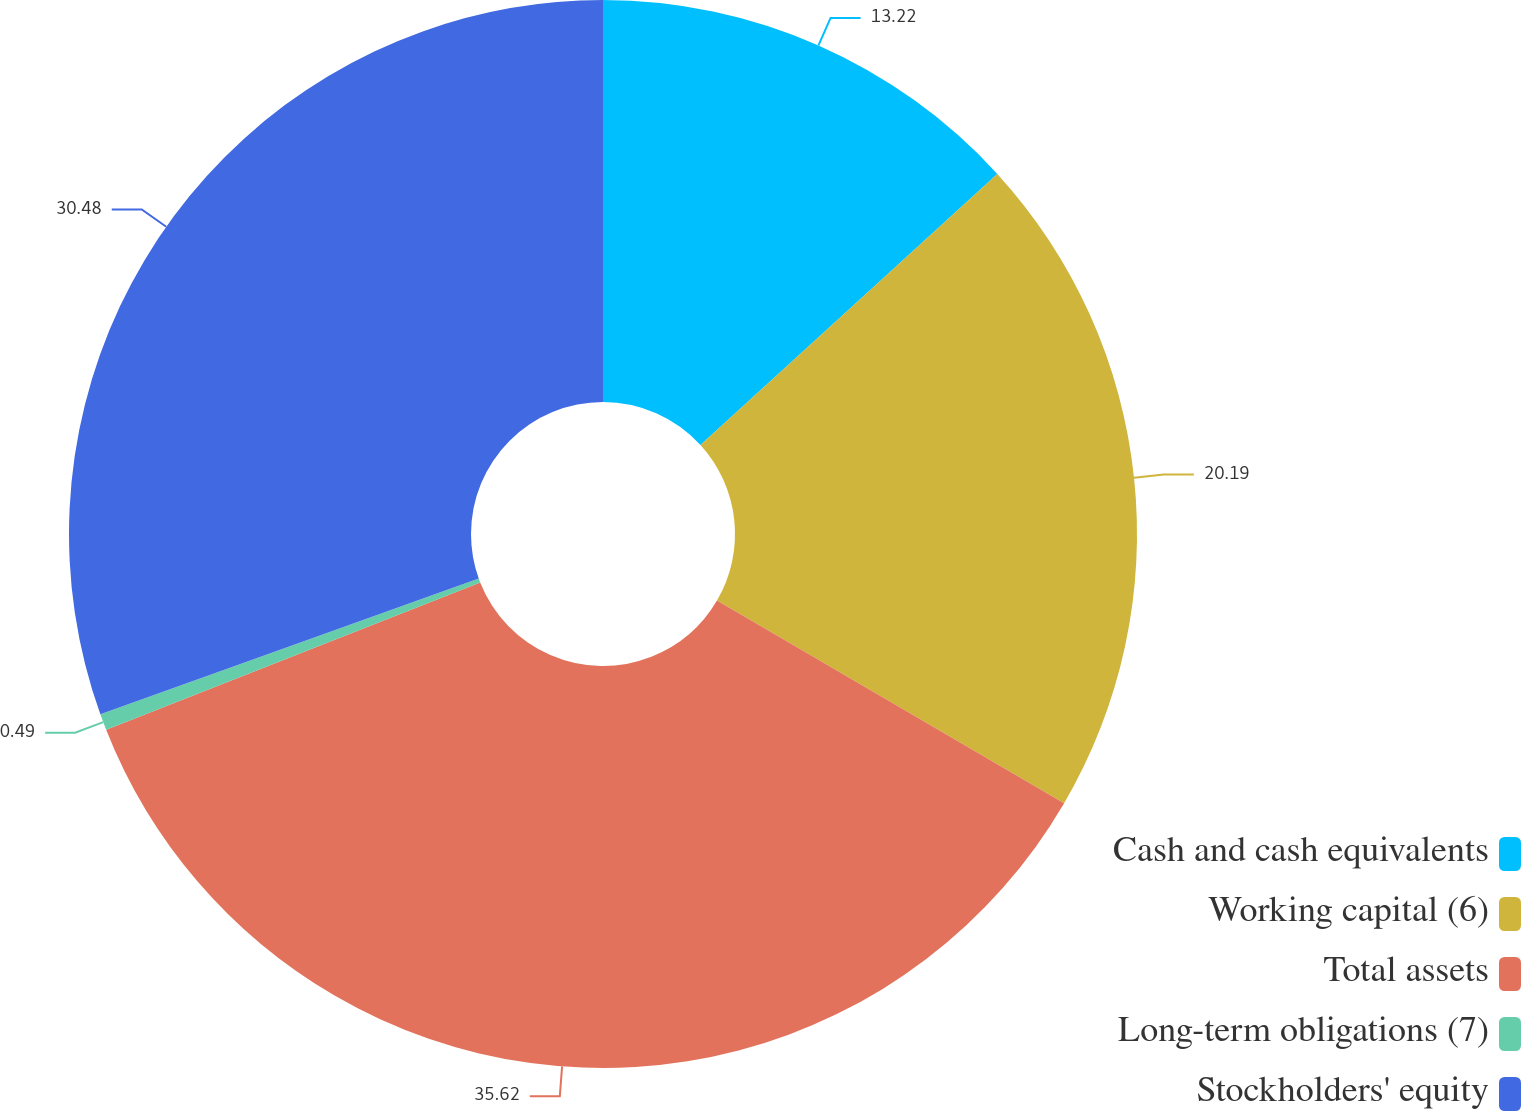Convert chart. <chart><loc_0><loc_0><loc_500><loc_500><pie_chart><fcel>Cash and cash equivalents<fcel>Working capital (6)<fcel>Total assets<fcel>Long-term obligations (7)<fcel>Stockholders' equity<nl><fcel>13.22%<fcel>20.19%<fcel>35.61%<fcel>0.49%<fcel>30.48%<nl></chart> 